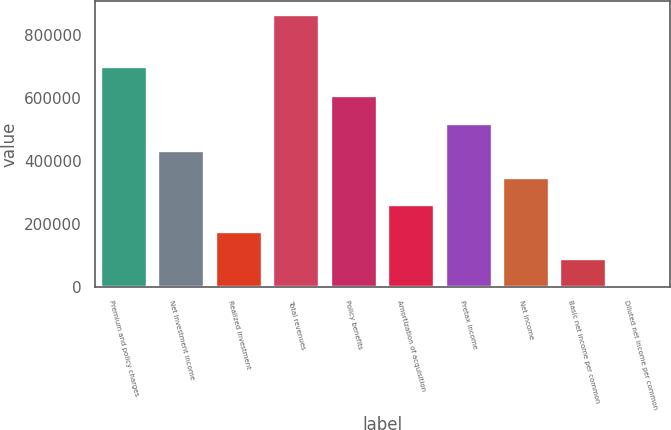<chart> <loc_0><loc_0><loc_500><loc_500><bar_chart><fcel>Premium and policy charges<fcel>Net investment income<fcel>Realized investment<fcel>Total revenues<fcel>Policy benefits<fcel>Amortization of acquisition<fcel>Pretax income<fcel>Net income<fcel>Basic net income per common<fcel>Diluted net income per common<nl><fcel>697096<fcel>431808<fcel>172724<fcel>863614<fcel>604530<fcel>259085<fcel>518169<fcel>345446<fcel>86362.7<fcel>1.41<nl></chart> 